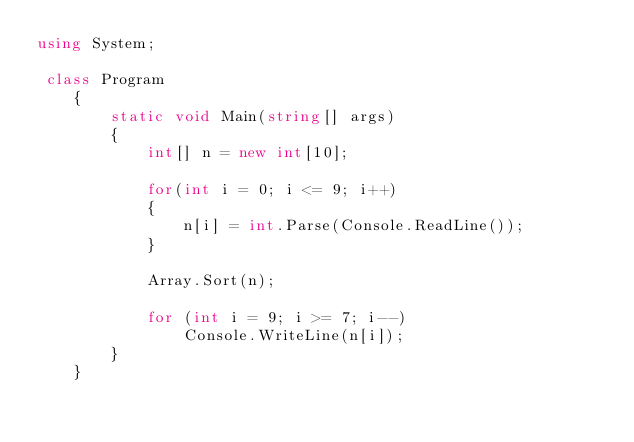<code> <loc_0><loc_0><loc_500><loc_500><_C#_>using System;   

 class Program
    {
        static void Main(string[] args)
        {
            int[] n = new int[10];
            
            for(int i = 0; i <= 9; i++)
            {
                n[i] = int.Parse(Console.ReadLine());
            }

            Array.Sort(n);

            for (int i = 9; i >= 7; i--)
                Console.WriteLine(n[i]);
        }
    }</code> 